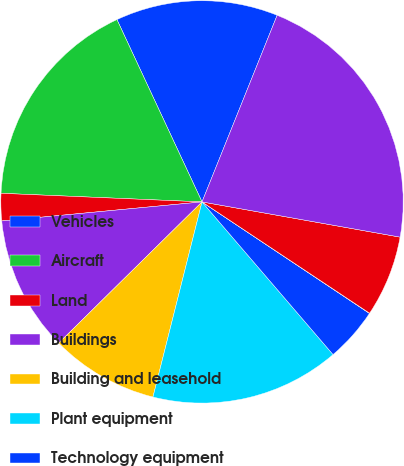<chart> <loc_0><loc_0><loc_500><loc_500><pie_chart><fcel>Vehicles<fcel>Aircraft<fcel>Land<fcel>Buildings<fcel>Building and leasehold<fcel>Plant equipment<fcel>Technology equipment<fcel>Equipment under operating<fcel>Construction-in-progress<fcel>Less Accumulated depreciation<nl><fcel>13.04%<fcel>17.37%<fcel>2.19%<fcel>10.87%<fcel>8.7%<fcel>15.21%<fcel>4.36%<fcel>0.02%<fcel>6.53%<fcel>21.71%<nl></chart> 